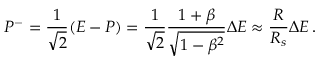<formula> <loc_0><loc_0><loc_500><loc_500>P ^ { - } = \frac { 1 } { \sqrt { 2 } } ( E - P ) = \frac { 1 } { \sqrt { 2 } } \frac { 1 + \beta } { \sqrt { 1 - \beta ^ { 2 } } } \Delta E \approx \frac { R } { R _ { s } } \Delta E \, .</formula> 